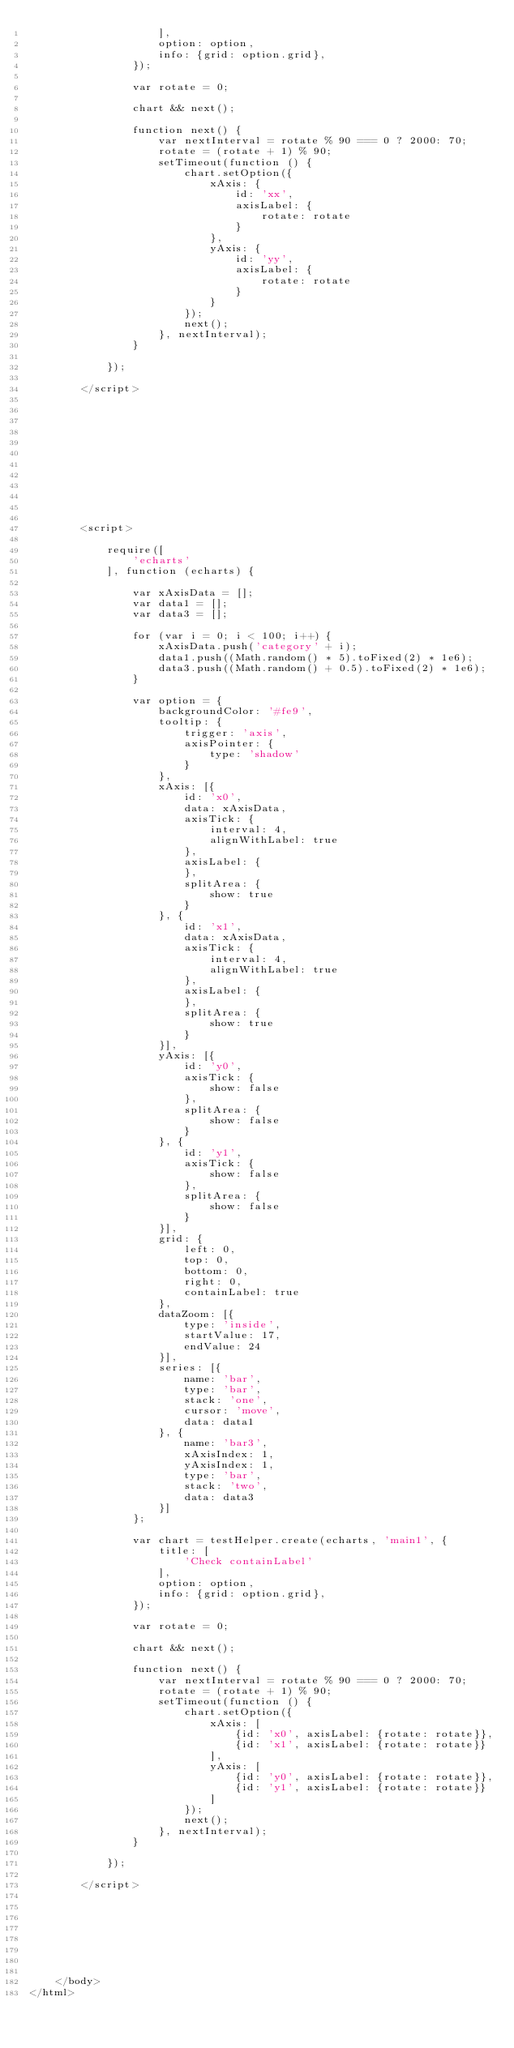<code> <loc_0><loc_0><loc_500><loc_500><_HTML_>                    ],
                    option: option,
                    info: {grid: option.grid},
                });

                var rotate = 0;

                chart && next();

                function next() {
                    var nextInterval = rotate % 90 === 0 ? 2000: 70;
                    rotate = (rotate + 1) % 90;
                    setTimeout(function () {
                        chart.setOption({
                            xAxis: {
                                id: 'xx',
                                axisLabel: {
                                    rotate: rotate
                                }
                            },
                            yAxis: {
                                id: 'yy',
                                axisLabel: {
                                    rotate: rotate
                                }
                            }
                        });
                        next();
                    }, nextInterval);
                }

            });

        </script>












        <script>

            require([
                'echarts'
            ], function (echarts) {

                var xAxisData = [];
                var data1 = [];
                var data3 = [];

                for (var i = 0; i < 100; i++) {
                    xAxisData.push('category' + i);
                    data1.push((Math.random() * 5).toFixed(2) * 1e6);
                    data3.push((Math.random() + 0.5).toFixed(2) * 1e6);
                }

                var option = {
                    backgroundColor: '#fe9',
                    tooltip: {
                        trigger: 'axis',
                        axisPointer: {
                            type: 'shadow'
                        }
                    },
                    xAxis: [{
                        id: 'x0',
                        data: xAxisData,
                        axisTick: {
                            interval: 4,
                            alignWithLabel: true
                        },
                        axisLabel: {
                        },
                        splitArea: {
                            show: true
                        }
                    }, {
                        id: 'x1',
                        data: xAxisData,
                        axisTick: {
                            interval: 4,
                            alignWithLabel: true
                        },
                        axisLabel: {
                        },
                        splitArea: {
                            show: true
                        }
                    }],
                    yAxis: [{
                        id: 'y0',
                        axisTick: {
                            show: false
                        },
                        splitArea: {
                            show: false
                        }
                    }, {
                        id: 'y1',
                        axisTick: {
                            show: false
                        },
                        splitArea: {
                            show: false
                        }
                    }],
                    grid: {
                        left: 0,
                        top: 0,
                        bottom: 0,
                        right: 0,
                        containLabel: true
                    },
                    dataZoom: [{
                        type: 'inside',
                        startValue: 17,
                        endValue: 24
                    }],
                    series: [{
                        name: 'bar',
                        type: 'bar',
                        stack: 'one',
                        cursor: 'move',
                        data: data1
                    }, {
                        name: 'bar3',
                        xAxisIndex: 1,
                        yAxisIndex: 1,
                        type: 'bar',
                        stack: 'two',
                        data: data3
                    }]
                };

                var chart = testHelper.create(echarts, 'main1', {
                    title: [
                        'Check containLabel'
                    ],
                    option: option,
                    info: {grid: option.grid},
                });

                var rotate = 0;

                chart && next();

                function next() {
                    var nextInterval = rotate % 90 === 0 ? 2000: 70;
                    rotate = (rotate + 1) % 90;
                    setTimeout(function () {
                        chart.setOption({
                            xAxis: [
                                {id: 'x0', axisLabel: {rotate: rotate}},
                                {id: 'x1', axisLabel: {rotate: rotate}}
                            ],
                            yAxis: [
                                {id: 'y0', axisLabel: {rotate: rotate}},
                                {id: 'y1', axisLabel: {rotate: rotate}}
                            ]
                        });
                        next();
                    }, nextInterval);
                }

            });

        </script>








    </body>
</html></code> 